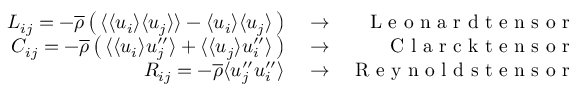Convert formula to latex. <formula><loc_0><loc_0><loc_500><loc_500>\begin{array} { r l r } { L _ { i j } = - \overline { \rho } \left ( \, \langle { \langle u _ { i } \rangle \langle u _ { j } \rangle } \rangle - \langle u _ { i } \rangle \langle u _ { j } \rangle \, \right ) } & \rightarrow } & { L e o n a r d t e n s o r } \\ { C _ { i j } = - \overline { \rho } \left ( \, \langle { \langle u _ { i } \rangle u _ { j } ^ { \prime \prime } } \rangle + \langle { \langle u _ { j } \rangle u _ { i } ^ { \prime \prime } } \rangle \, \right ) } & \rightarrow } & { C l a r c k t e n s o r } \\ { R _ { i j } = - \overline { \rho } \langle { u _ { j } ^ { \prime \prime } u _ { i } ^ { \prime \prime } } \rangle } & \rightarrow } & { R e y n o l d s t e n s o r } \end{array}</formula> 